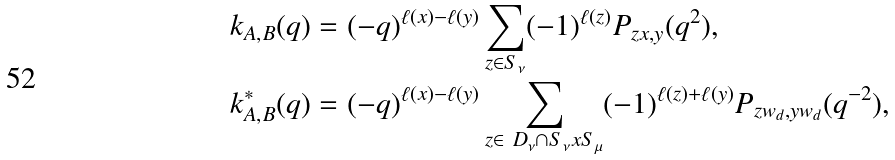Convert formula to latex. <formula><loc_0><loc_0><loc_500><loc_500>k _ { A , B } ( q ) & = ( - q ) ^ { \ell ( x ) - \ell ( y ) } \sum _ { z \in S _ { \nu } } ( - 1 ) ^ { \ell ( z ) } P _ { z x , y } ( q ^ { 2 } ) , \\ k _ { A , B } ^ { * } ( q ) & = ( - q ) ^ { \ell ( x ) - \ell ( y ) } \sum _ { z \in \ D _ { \nu } \cap S _ { \nu } x S _ { \mu } } ( - 1 ) ^ { \ell ( z ) + \ell ( y ) } P _ { z w _ { d } , y w _ { d } } ( q ^ { - 2 } ) ,</formula> 